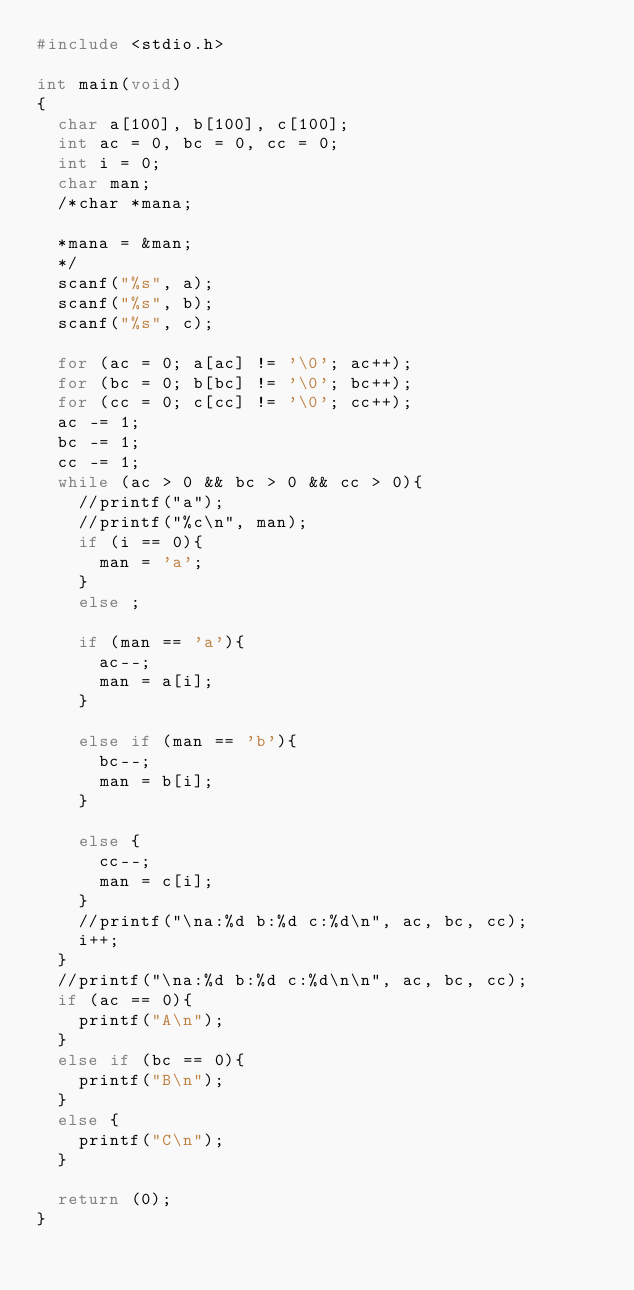Convert code to text. <code><loc_0><loc_0><loc_500><loc_500><_C_>#include <stdio.h>

int main(void)
{
	char a[100], b[100], c[100];
	int ac = 0, bc = 0, cc = 0;
	int i = 0;
	char man;
	/*char *mana;
	
	*mana = &man;
	*/
	scanf("%s", a);
	scanf("%s", b);
	scanf("%s", c);
	
	for (ac = 0; a[ac] != '\0'; ac++);
	for (bc = 0; b[bc] != '\0'; bc++);
	for (cc = 0; c[cc] != '\0'; cc++);
	ac -= 1;
	bc -= 1;
	cc -= 1;
	while (ac > 0 && bc > 0 && cc > 0){
		//printf("a");
		//printf("%c\n", man);
		if (i == 0){
			man = 'a';
		}
		else ;
		
		if (man == 'a'){
			ac--;
			man = a[i];
		}
			
		else if (man == 'b'){
			bc--;
			man = b[i];
		}
			
		else {
			cc--;
			man = c[i];
		}
		//printf("\na:%d b:%d c:%d\n", ac, bc, cc);
		i++;
	}
	//printf("\na:%d b:%d c:%d\n\n", ac, bc, cc);
	if (ac == 0){
		printf("A\n");
	}
	else if (bc == 0){
		printf("B\n");
	}
	else {
		printf("C\n");
	}
	
	return (0);
}</code> 